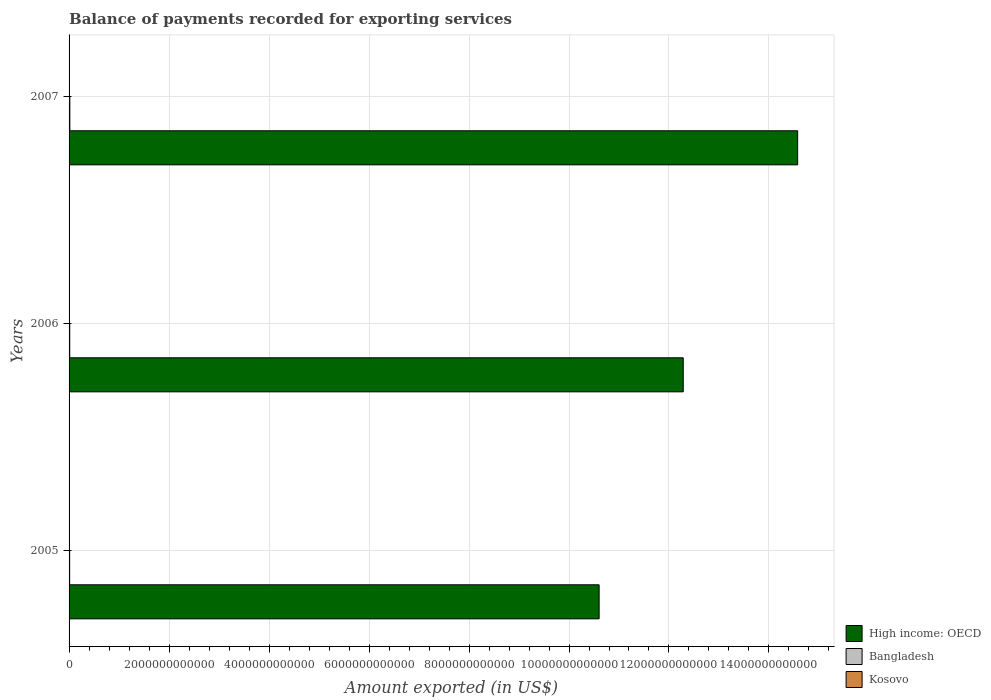How many different coloured bars are there?
Give a very brief answer. 3. What is the amount exported in Kosovo in 2006?
Your answer should be very brief. 7.50e+08. Across all years, what is the maximum amount exported in Bangladesh?
Ensure brevity in your answer.  1.52e+1. Across all years, what is the minimum amount exported in Bangladesh?
Provide a short and direct response. 1.13e+1. In which year was the amount exported in High income: OECD minimum?
Make the answer very short. 2005. What is the total amount exported in Bangladesh in the graph?
Your answer should be very brief. 3.98e+1. What is the difference between the amount exported in Kosovo in 2006 and that in 2007?
Make the answer very short. -2.40e+08. What is the difference between the amount exported in Bangladesh in 2006 and the amount exported in High income: OECD in 2005?
Keep it short and to the point. -1.06e+13. What is the average amount exported in High income: OECD per year?
Offer a very short reply. 1.25e+13. In the year 2005, what is the difference between the amount exported in High income: OECD and amount exported in Kosovo?
Your response must be concise. 1.06e+13. What is the ratio of the amount exported in High income: OECD in 2006 to that in 2007?
Offer a terse response. 0.84. Is the difference between the amount exported in High income: OECD in 2005 and 2007 greater than the difference between the amount exported in Kosovo in 2005 and 2007?
Provide a succinct answer. No. What is the difference between the highest and the second highest amount exported in Bangladesh?
Offer a very short reply. 1.92e+09. What is the difference between the highest and the lowest amount exported in Kosovo?
Make the answer very short. 3.66e+08. Is the sum of the amount exported in Kosovo in 2005 and 2006 greater than the maximum amount exported in High income: OECD across all years?
Keep it short and to the point. No. What does the 3rd bar from the bottom in 2006 represents?
Your answer should be compact. Kosovo. How many bars are there?
Offer a very short reply. 9. Are all the bars in the graph horizontal?
Your answer should be very brief. Yes. How many years are there in the graph?
Your answer should be very brief. 3. What is the difference between two consecutive major ticks on the X-axis?
Give a very brief answer. 2.00e+12. Does the graph contain any zero values?
Your response must be concise. No. Does the graph contain grids?
Provide a succinct answer. Yes. How are the legend labels stacked?
Offer a terse response. Vertical. What is the title of the graph?
Your answer should be compact. Balance of payments recorded for exporting services. Does "Mauritius" appear as one of the legend labels in the graph?
Your answer should be very brief. No. What is the label or title of the X-axis?
Offer a terse response. Amount exported (in US$). What is the label or title of the Y-axis?
Ensure brevity in your answer.  Years. What is the Amount exported (in US$) of High income: OECD in 2005?
Offer a terse response. 1.06e+13. What is the Amount exported (in US$) of Bangladesh in 2005?
Offer a terse response. 1.13e+1. What is the Amount exported (in US$) of Kosovo in 2005?
Your response must be concise. 6.25e+08. What is the Amount exported (in US$) of High income: OECD in 2006?
Provide a short and direct response. 1.23e+13. What is the Amount exported (in US$) in Bangladesh in 2006?
Keep it short and to the point. 1.33e+1. What is the Amount exported (in US$) in Kosovo in 2006?
Provide a short and direct response. 7.50e+08. What is the Amount exported (in US$) of High income: OECD in 2007?
Provide a short and direct response. 1.46e+13. What is the Amount exported (in US$) of Bangladesh in 2007?
Ensure brevity in your answer.  1.52e+1. What is the Amount exported (in US$) in Kosovo in 2007?
Keep it short and to the point. 9.91e+08. Across all years, what is the maximum Amount exported (in US$) of High income: OECD?
Ensure brevity in your answer.  1.46e+13. Across all years, what is the maximum Amount exported (in US$) in Bangladesh?
Give a very brief answer. 1.52e+1. Across all years, what is the maximum Amount exported (in US$) of Kosovo?
Your response must be concise. 9.91e+08. Across all years, what is the minimum Amount exported (in US$) of High income: OECD?
Offer a very short reply. 1.06e+13. Across all years, what is the minimum Amount exported (in US$) in Bangladesh?
Offer a very short reply. 1.13e+1. Across all years, what is the minimum Amount exported (in US$) of Kosovo?
Keep it short and to the point. 6.25e+08. What is the total Amount exported (in US$) in High income: OECD in the graph?
Offer a terse response. 3.75e+13. What is the total Amount exported (in US$) of Bangladesh in the graph?
Provide a short and direct response. 3.98e+1. What is the total Amount exported (in US$) of Kosovo in the graph?
Keep it short and to the point. 2.37e+09. What is the difference between the Amount exported (in US$) of High income: OECD in 2005 and that in 2006?
Keep it short and to the point. -1.68e+12. What is the difference between the Amount exported (in US$) of Bangladesh in 2005 and that in 2006?
Provide a succinct answer. -1.95e+09. What is the difference between the Amount exported (in US$) of Kosovo in 2005 and that in 2006?
Offer a very short reply. -1.26e+08. What is the difference between the Amount exported (in US$) in High income: OECD in 2005 and that in 2007?
Provide a short and direct response. -3.97e+12. What is the difference between the Amount exported (in US$) in Bangladesh in 2005 and that in 2007?
Keep it short and to the point. -3.87e+09. What is the difference between the Amount exported (in US$) in Kosovo in 2005 and that in 2007?
Give a very brief answer. -3.66e+08. What is the difference between the Amount exported (in US$) in High income: OECD in 2006 and that in 2007?
Give a very brief answer. -2.29e+12. What is the difference between the Amount exported (in US$) in Bangladesh in 2006 and that in 2007?
Offer a very short reply. -1.92e+09. What is the difference between the Amount exported (in US$) in Kosovo in 2006 and that in 2007?
Your response must be concise. -2.40e+08. What is the difference between the Amount exported (in US$) in High income: OECD in 2005 and the Amount exported (in US$) in Bangladesh in 2006?
Keep it short and to the point. 1.06e+13. What is the difference between the Amount exported (in US$) of High income: OECD in 2005 and the Amount exported (in US$) of Kosovo in 2006?
Keep it short and to the point. 1.06e+13. What is the difference between the Amount exported (in US$) of Bangladesh in 2005 and the Amount exported (in US$) of Kosovo in 2006?
Offer a terse response. 1.06e+1. What is the difference between the Amount exported (in US$) in High income: OECD in 2005 and the Amount exported (in US$) in Bangladesh in 2007?
Your answer should be compact. 1.06e+13. What is the difference between the Amount exported (in US$) of High income: OECD in 2005 and the Amount exported (in US$) of Kosovo in 2007?
Give a very brief answer. 1.06e+13. What is the difference between the Amount exported (in US$) in Bangladesh in 2005 and the Amount exported (in US$) in Kosovo in 2007?
Provide a short and direct response. 1.03e+1. What is the difference between the Amount exported (in US$) of High income: OECD in 2006 and the Amount exported (in US$) of Bangladesh in 2007?
Give a very brief answer. 1.23e+13. What is the difference between the Amount exported (in US$) of High income: OECD in 2006 and the Amount exported (in US$) of Kosovo in 2007?
Your response must be concise. 1.23e+13. What is the difference between the Amount exported (in US$) of Bangladesh in 2006 and the Amount exported (in US$) of Kosovo in 2007?
Make the answer very short. 1.23e+1. What is the average Amount exported (in US$) of High income: OECD per year?
Give a very brief answer. 1.25e+13. What is the average Amount exported (in US$) in Bangladesh per year?
Offer a very short reply. 1.33e+1. What is the average Amount exported (in US$) in Kosovo per year?
Provide a succinct answer. 7.89e+08. In the year 2005, what is the difference between the Amount exported (in US$) of High income: OECD and Amount exported (in US$) of Bangladesh?
Keep it short and to the point. 1.06e+13. In the year 2005, what is the difference between the Amount exported (in US$) of High income: OECD and Amount exported (in US$) of Kosovo?
Your response must be concise. 1.06e+13. In the year 2005, what is the difference between the Amount exported (in US$) in Bangladesh and Amount exported (in US$) in Kosovo?
Keep it short and to the point. 1.07e+1. In the year 2006, what is the difference between the Amount exported (in US$) in High income: OECD and Amount exported (in US$) in Bangladesh?
Offer a very short reply. 1.23e+13. In the year 2006, what is the difference between the Amount exported (in US$) of High income: OECD and Amount exported (in US$) of Kosovo?
Provide a short and direct response. 1.23e+13. In the year 2006, what is the difference between the Amount exported (in US$) of Bangladesh and Amount exported (in US$) of Kosovo?
Offer a terse response. 1.25e+1. In the year 2007, what is the difference between the Amount exported (in US$) of High income: OECD and Amount exported (in US$) of Bangladesh?
Your response must be concise. 1.46e+13. In the year 2007, what is the difference between the Amount exported (in US$) in High income: OECD and Amount exported (in US$) in Kosovo?
Provide a succinct answer. 1.46e+13. In the year 2007, what is the difference between the Amount exported (in US$) in Bangladesh and Amount exported (in US$) in Kosovo?
Your response must be concise. 1.42e+1. What is the ratio of the Amount exported (in US$) of High income: OECD in 2005 to that in 2006?
Provide a succinct answer. 0.86. What is the ratio of the Amount exported (in US$) of Bangladesh in 2005 to that in 2006?
Provide a short and direct response. 0.85. What is the ratio of the Amount exported (in US$) of Kosovo in 2005 to that in 2006?
Make the answer very short. 0.83. What is the ratio of the Amount exported (in US$) in High income: OECD in 2005 to that in 2007?
Your answer should be very brief. 0.73. What is the ratio of the Amount exported (in US$) in Bangladesh in 2005 to that in 2007?
Ensure brevity in your answer.  0.74. What is the ratio of the Amount exported (in US$) of Kosovo in 2005 to that in 2007?
Ensure brevity in your answer.  0.63. What is the ratio of the Amount exported (in US$) in High income: OECD in 2006 to that in 2007?
Make the answer very short. 0.84. What is the ratio of the Amount exported (in US$) of Bangladesh in 2006 to that in 2007?
Provide a succinct answer. 0.87. What is the ratio of the Amount exported (in US$) in Kosovo in 2006 to that in 2007?
Your answer should be compact. 0.76. What is the difference between the highest and the second highest Amount exported (in US$) of High income: OECD?
Make the answer very short. 2.29e+12. What is the difference between the highest and the second highest Amount exported (in US$) in Bangladesh?
Give a very brief answer. 1.92e+09. What is the difference between the highest and the second highest Amount exported (in US$) in Kosovo?
Offer a terse response. 2.40e+08. What is the difference between the highest and the lowest Amount exported (in US$) in High income: OECD?
Offer a very short reply. 3.97e+12. What is the difference between the highest and the lowest Amount exported (in US$) in Bangladesh?
Provide a short and direct response. 3.87e+09. What is the difference between the highest and the lowest Amount exported (in US$) of Kosovo?
Provide a short and direct response. 3.66e+08. 